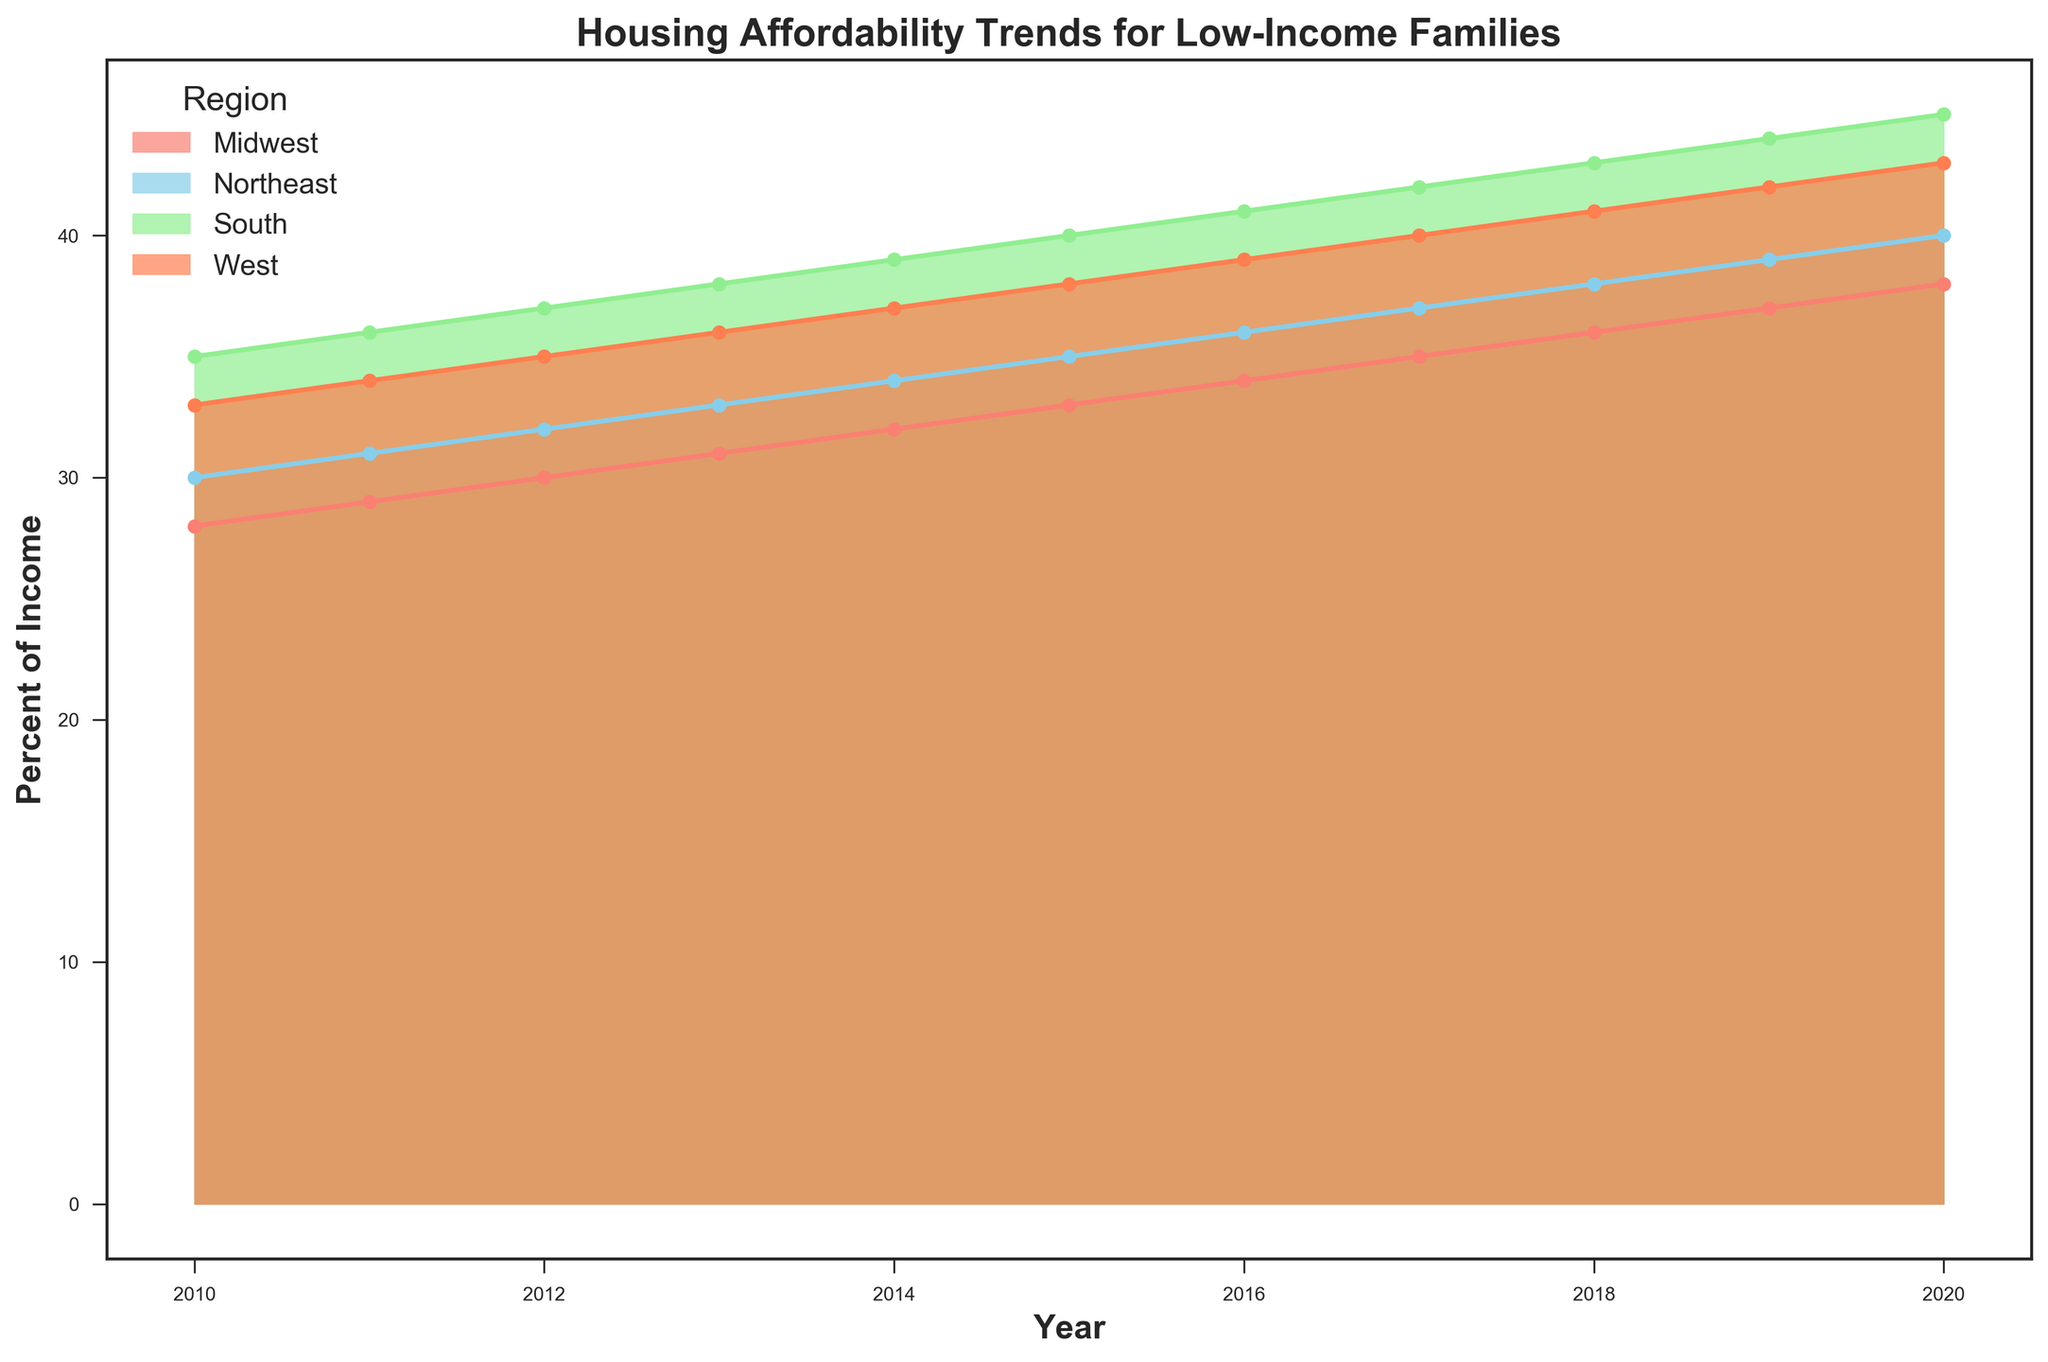What's the trend in housing affordability for the South from 2010 to 2020? The data shows the South's housing affordability started at 35% of income in 2010 and increased to 45% of income by 2020, indicating a rising trend where low-income families in the South are spending a higher percentage of their income on housing.
Answer: Rising trend Which region had the smallest increase in percent of income spent on housing from 2010 to 2020? By comparing the initial and final percentages, the Midwest went from 28% in 2010 to 38% in 2020, an increase of 10%. For the Northeast, it went from 30% to 40%, South from 35% to 45%, and West from 33% to 43%. The Midwest had the smallest increase.
Answer: Midwest In 2017, which region had the highest percentage of income spent on housing? By looking at the data points for 2017, the South had the highest percentage at 42%, followed by the West at 40%, Northeast at 37%, and Midwest at 35%.
Answer: South What is the overall average percentage of income spent on housing across all regions in 2020? Calculate the average by summing the percentages for all regions in 2020 and dividing by the number of regions: (40 + 38 + 45 + 43) / 4 = 166 / 4.
Answer: 41.5 How does the percentage of income spent on housing in the West in 2015 compare to the Midwest in 2019? The West in 2015 spent 38% of income on housing, while the Midwest in 2019 spent 37%. The West was 1% higher.
Answer: The West was 1% higher Which year did the Northeast surpass 35% of income spent on housing? By observing the trend, the Northeast surpassed 35% for the first time in 2018 when it reached 38%.
Answer: 2018 What is the difference in the percentage of income spent on housing between the Midwest and the Northeast in 2013? Look at the 2013 data points: the Midwest is at 31%, and the Northeast is at 33%. The difference is 33% - 31% = 2%.
Answer: 2% Which region shows the most significant increase in housing costs relative to income in any given year? The South shows the most significant increase in a single year, increasing from 44% in 2019 to 45% in 2020, a 1% jump, which is significant among the given regions.
Answer: South 